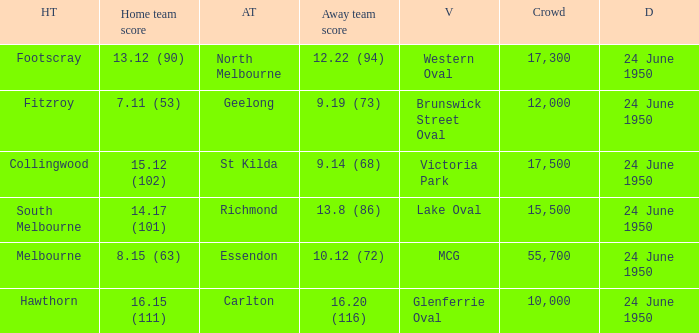Who was the home team for the game where North Melbourne was the away team? Footscray. 